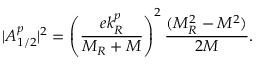Convert formula to latex. <formula><loc_0><loc_0><loc_500><loc_500>| A _ { 1 / 2 } ^ { p } | ^ { 2 } = \left ( \frac { e k _ { R } ^ { p } } { M _ { R } + M } \right ) ^ { 2 } \frac { ( M _ { R } ^ { 2 } - M ^ { 2 } ) } { 2 M } .</formula> 